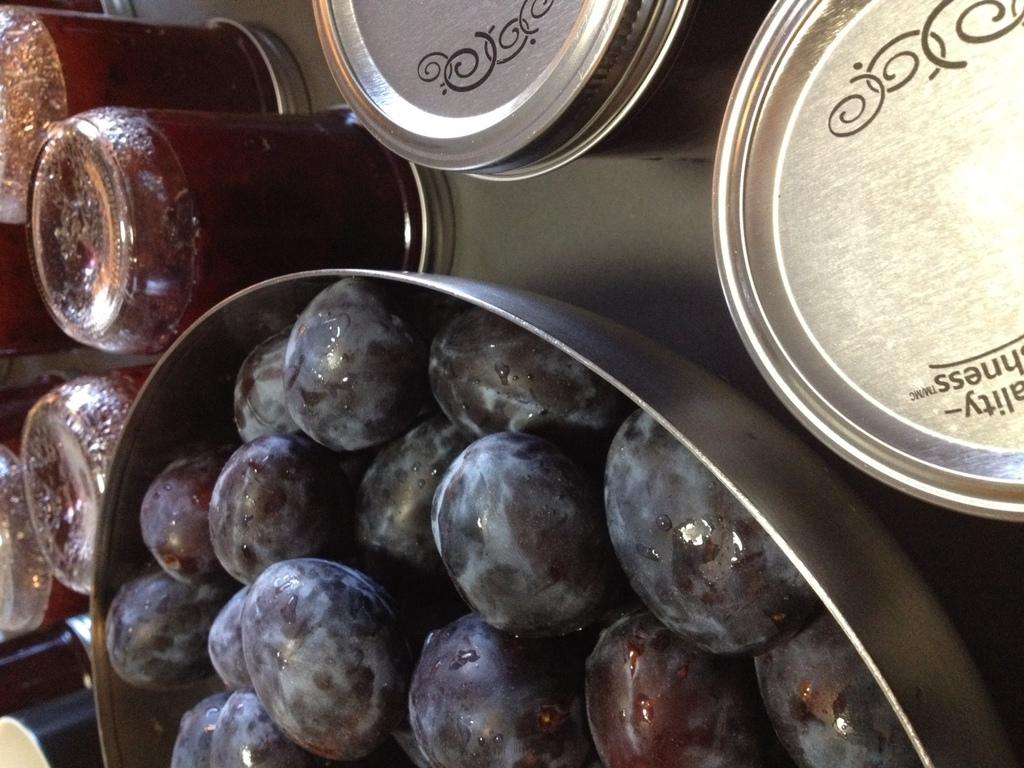What type of fruit is in the bowl in the image? There are grapes in a bowl in the image. What can be seen in the background of the image? In the background, there are juice jars placed on a surface. What type of locket is the sister wearing in the image? There is no sister or locket present in the image. Can you describe the bee's behavior in the image? There are no bees present in the image. 